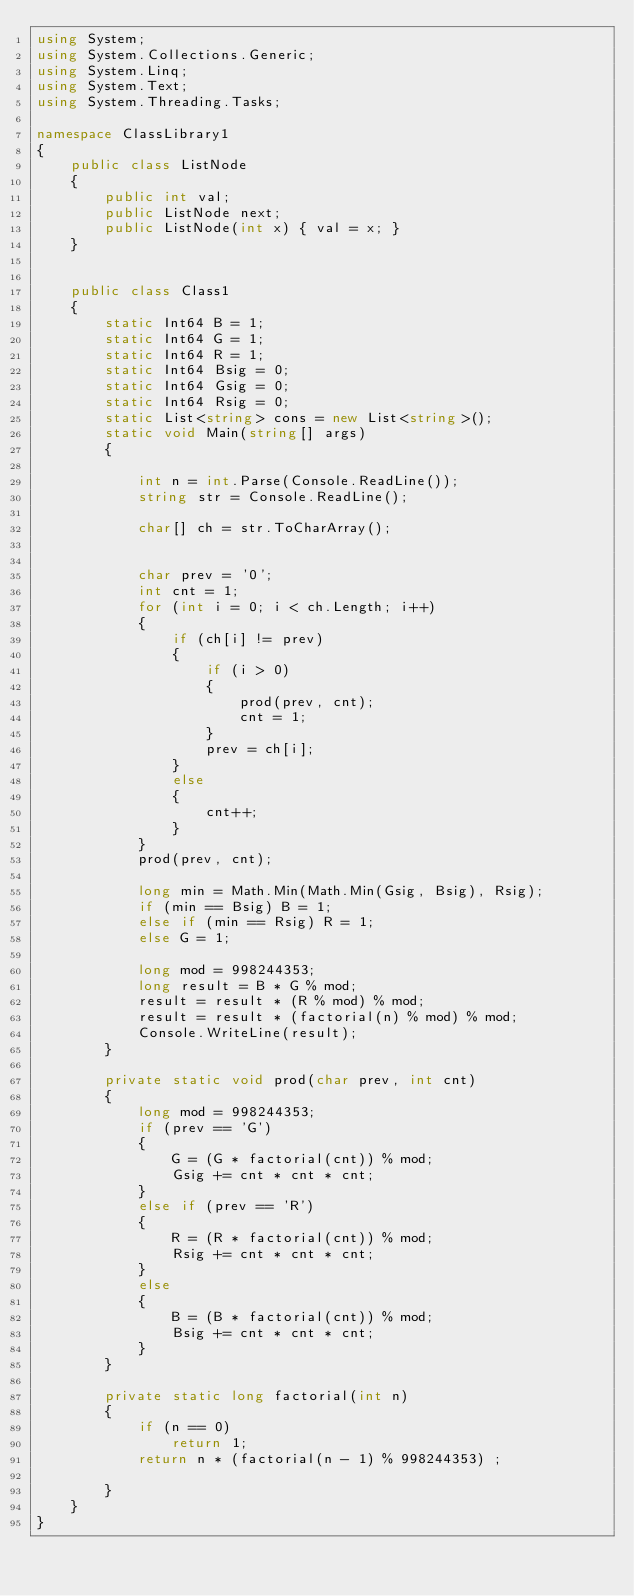Convert code to text. <code><loc_0><loc_0><loc_500><loc_500><_C#_>using System;
using System.Collections.Generic;
using System.Linq;
using System.Text;
using System.Threading.Tasks;

namespace ClassLibrary1
{
    public class ListNode
    {
        public int val;
        public ListNode next;
        public ListNode(int x) { val = x; }
    }


    public class Class1
    {
        static Int64 B = 1;
        static Int64 G = 1;
        static Int64 R = 1;
        static Int64 Bsig = 0;
        static Int64 Gsig = 0;
        static Int64 Rsig = 0;
        static List<string> cons = new List<string>();
        static void Main(string[] args)
        {

            int n = int.Parse(Console.ReadLine());
            string str = Console.ReadLine();

            char[] ch = str.ToCharArray();


            char prev = '0';
            int cnt = 1;
            for (int i = 0; i < ch.Length; i++)
            {
                if (ch[i] != prev)
                {
                    if (i > 0)
                    {
                        prod(prev, cnt);
                        cnt = 1;
                    }
                    prev = ch[i];
                }
                else
                {
                    cnt++;
                }
            }
            prod(prev, cnt);

            long min = Math.Min(Math.Min(Gsig, Bsig), Rsig);
            if (min == Bsig) B = 1;
            else if (min == Rsig) R = 1;
            else G = 1;

            long mod = 998244353;
            long result = B * G % mod;
            result = result * (R % mod) % mod;
            result = result * (factorial(n) % mod) % mod;
            Console.WriteLine(result);
        }

        private static void prod(char prev, int cnt)
        {
            long mod = 998244353;
            if (prev == 'G')
            {
                G = (G * factorial(cnt)) % mod;
                Gsig += cnt * cnt * cnt;
            }
            else if (prev == 'R')
            {
                R = (R * factorial(cnt)) % mod;
                Rsig += cnt * cnt * cnt;
            }
            else
            {
                B = (B * factorial(cnt)) % mod;
                Bsig += cnt * cnt * cnt;
            }
        }

        private static long factorial(int n)
        {
            if (n == 0)
                return 1;
            return n * (factorial(n - 1) % 998244353) ;

        }
    }
}</code> 